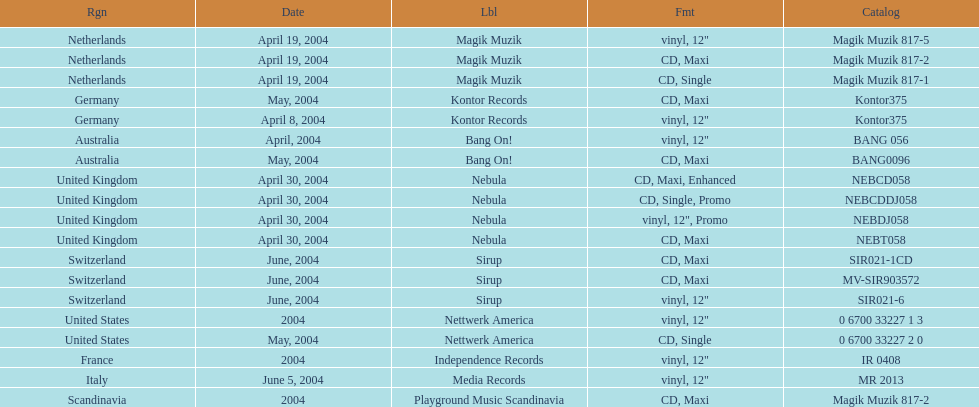How many catalogs were released? 19. 